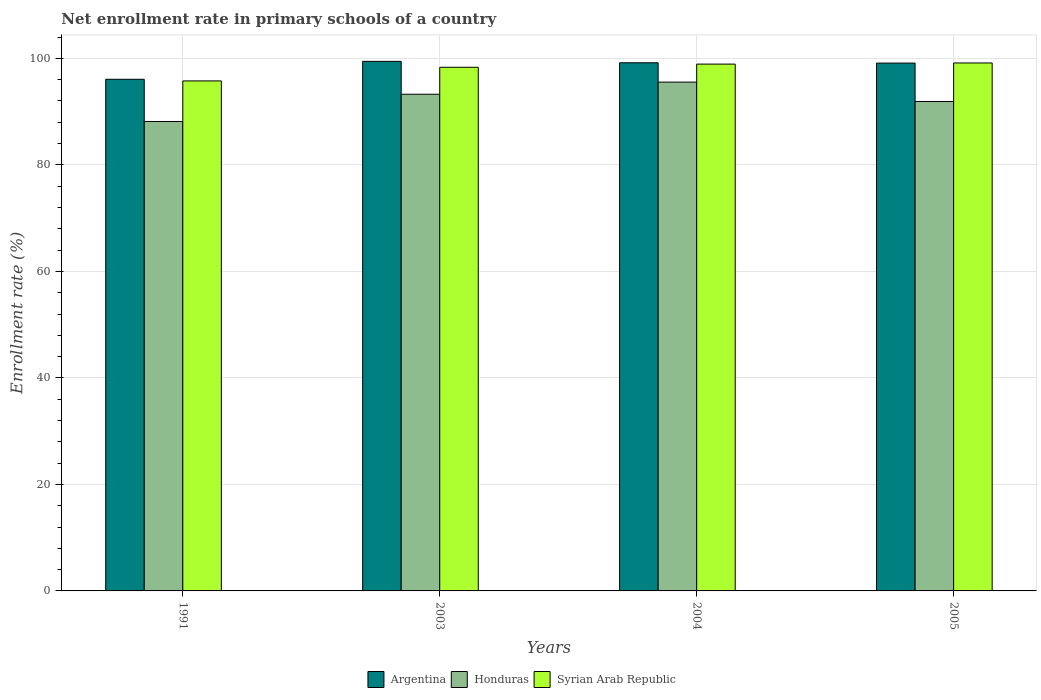How many different coloured bars are there?
Offer a very short reply. 3. How many groups of bars are there?
Offer a very short reply. 4. Are the number of bars per tick equal to the number of legend labels?
Provide a short and direct response. Yes. What is the label of the 2nd group of bars from the left?
Provide a short and direct response. 2003. What is the enrollment rate in primary schools in Syrian Arab Republic in 2003?
Offer a terse response. 98.33. Across all years, what is the maximum enrollment rate in primary schools in Syrian Arab Republic?
Your answer should be compact. 99.14. Across all years, what is the minimum enrollment rate in primary schools in Argentina?
Make the answer very short. 96.08. What is the total enrollment rate in primary schools in Argentina in the graph?
Give a very brief answer. 393.82. What is the difference between the enrollment rate in primary schools in Syrian Arab Republic in 1991 and that in 2004?
Your answer should be very brief. -3.16. What is the difference between the enrollment rate in primary schools in Argentina in 2003 and the enrollment rate in primary schools in Honduras in 2004?
Your response must be concise. 3.9. What is the average enrollment rate in primary schools in Syrian Arab Republic per year?
Offer a very short reply. 98.04. In the year 2005, what is the difference between the enrollment rate in primary schools in Honduras and enrollment rate in primary schools in Argentina?
Provide a succinct answer. -7.21. What is the ratio of the enrollment rate in primary schools in Honduras in 1991 to that in 2005?
Ensure brevity in your answer.  0.96. Is the enrollment rate in primary schools in Syrian Arab Republic in 2003 less than that in 2004?
Keep it short and to the point. Yes. Is the difference between the enrollment rate in primary schools in Honduras in 1991 and 2003 greater than the difference between the enrollment rate in primary schools in Argentina in 1991 and 2003?
Ensure brevity in your answer.  No. What is the difference between the highest and the second highest enrollment rate in primary schools in Honduras?
Ensure brevity in your answer.  2.28. What is the difference between the highest and the lowest enrollment rate in primary schools in Syrian Arab Republic?
Keep it short and to the point. 3.37. What does the 3rd bar from the left in 2005 represents?
Your answer should be very brief. Syrian Arab Republic. What does the 2nd bar from the right in 2005 represents?
Offer a terse response. Honduras. Is it the case that in every year, the sum of the enrollment rate in primary schools in Syrian Arab Republic and enrollment rate in primary schools in Honduras is greater than the enrollment rate in primary schools in Argentina?
Your answer should be very brief. Yes. How many bars are there?
Offer a very short reply. 12. How many years are there in the graph?
Your answer should be compact. 4. What is the difference between two consecutive major ticks on the Y-axis?
Make the answer very short. 20. Are the values on the major ticks of Y-axis written in scientific E-notation?
Provide a short and direct response. No. Does the graph contain any zero values?
Your response must be concise. No. Where does the legend appear in the graph?
Your answer should be compact. Bottom center. What is the title of the graph?
Keep it short and to the point. Net enrollment rate in primary schools of a country. What is the label or title of the X-axis?
Offer a terse response. Years. What is the label or title of the Y-axis?
Your answer should be very brief. Enrollment rate (%). What is the Enrollment rate (%) of Argentina in 1991?
Give a very brief answer. 96.08. What is the Enrollment rate (%) in Honduras in 1991?
Keep it short and to the point. 88.15. What is the Enrollment rate (%) in Syrian Arab Republic in 1991?
Make the answer very short. 95.77. What is the Enrollment rate (%) of Argentina in 2003?
Your response must be concise. 99.44. What is the Enrollment rate (%) of Honduras in 2003?
Your response must be concise. 93.27. What is the Enrollment rate (%) of Syrian Arab Republic in 2003?
Your response must be concise. 98.33. What is the Enrollment rate (%) in Argentina in 2004?
Keep it short and to the point. 99.18. What is the Enrollment rate (%) of Honduras in 2004?
Keep it short and to the point. 95.55. What is the Enrollment rate (%) in Syrian Arab Republic in 2004?
Make the answer very short. 98.93. What is the Enrollment rate (%) of Argentina in 2005?
Your answer should be compact. 99.12. What is the Enrollment rate (%) of Honduras in 2005?
Provide a succinct answer. 91.91. What is the Enrollment rate (%) of Syrian Arab Republic in 2005?
Your answer should be very brief. 99.14. Across all years, what is the maximum Enrollment rate (%) in Argentina?
Provide a succinct answer. 99.44. Across all years, what is the maximum Enrollment rate (%) in Honduras?
Provide a short and direct response. 95.55. Across all years, what is the maximum Enrollment rate (%) of Syrian Arab Republic?
Ensure brevity in your answer.  99.14. Across all years, what is the minimum Enrollment rate (%) in Argentina?
Offer a very short reply. 96.08. Across all years, what is the minimum Enrollment rate (%) of Honduras?
Your response must be concise. 88.15. Across all years, what is the minimum Enrollment rate (%) in Syrian Arab Republic?
Your answer should be very brief. 95.77. What is the total Enrollment rate (%) in Argentina in the graph?
Your answer should be very brief. 393.82. What is the total Enrollment rate (%) in Honduras in the graph?
Give a very brief answer. 368.87. What is the total Enrollment rate (%) in Syrian Arab Republic in the graph?
Your answer should be very brief. 392.18. What is the difference between the Enrollment rate (%) of Argentina in 1991 and that in 2003?
Your response must be concise. -3.36. What is the difference between the Enrollment rate (%) in Honduras in 1991 and that in 2003?
Your response must be concise. -5.12. What is the difference between the Enrollment rate (%) in Syrian Arab Republic in 1991 and that in 2003?
Keep it short and to the point. -2.56. What is the difference between the Enrollment rate (%) of Argentina in 1991 and that in 2004?
Your answer should be compact. -3.1. What is the difference between the Enrollment rate (%) in Honduras in 1991 and that in 2004?
Offer a very short reply. -7.4. What is the difference between the Enrollment rate (%) of Syrian Arab Republic in 1991 and that in 2004?
Make the answer very short. -3.16. What is the difference between the Enrollment rate (%) of Argentina in 1991 and that in 2005?
Provide a short and direct response. -3.04. What is the difference between the Enrollment rate (%) in Honduras in 1991 and that in 2005?
Keep it short and to the point. -3.76. What is the difference between the Enrollment rate (%) of Syrian Arab Republic in 1991 and that in 2005?
Make the answer very short. -3.37. What is the difference between the Enrollment rate (%) in Argentina in 2003 and that in 2004?
Provide a short and direct response. 0.27. What is the difference between the Enrollment rate (%) in Honduras in 2003 and that in 2004?
Your answer should be very brief. -2.28. What is the difference between the Enrollment rate (%) in Syrian Arab Republic in 2003 and that in 2004?
Make the answer very short. -0.6. What is the difference between the Enrollment rate (%) of Argentina in 2003 and that in 2005?
Your answer should be compact. 0.33. What is the difference between the Enrollment rate (%) in Honduras in 2003 and that in 2005?
Provide a succinct answer. 1.36. What is the difference between the Enrollment rate (%) of Syrian Arab Republic in 2003 and that in 2005?
Provide a succinct answer. -0.81. What is the difference between the Enrollment rate (%) in Argentina in 2004 and that in 2005?
Provide a succinct answer. 0.06. What is the difference between the Enrollment rate (%) in Honduras in 2004 and that in 2005?
Your response must be concise. 3.64. What is the difference between the Enrollment rate (%) of Syrian Arab Republic in 2004 and that in 2005?
Offer a very short reply. -0.21. What is the difference between the Enrollment rate (%) of Argentina in 1991 and the Enrollment rate (%) of Honduras in 2003?
Your response must be concise. 2.81. What is the difference between the Enrollment rate (%) of Argentina in 1991 and the Enrollment rate (%) of Syrian Arab Republic in 2003?
Offer a terse response. -2.25. What is the difference between the Enrollment rate (%) of Honduras in 1991 and the Enrollment rate (%) of Syrian Arab Republic in 2003?
Give a very brief answer. -10.19. What is the difference between the Enrollment rate (%) of Argentina in 1991 and the Enrollment rate (%) of Honduras in 2004?
Your answer should be very brief. 0.53. What is the difference between the Enrollment rate (%) in Argentina in 1991 and the Enrollment rate (%) in Syrian Arab Republic in 2004?
Provide a short and direct response. -2.85. What is the difference between the Enrollment rate (%) in Honduras in 1991 and the Enrollment rate (%) in Syrian Arab Republic in 2004?
Your answer should be compact. -10.78. What is the difference between the Enrollment rate (%) in Argentina in 1991 and the Enrollment rate (%) in Honduras in 2005?
Keep it short and to the point. 4.17. What is the difference between the Enrollment rate (%) of Argentina in 1991 and the Enrollment rate (%) of Syrian Arab Republic in 2005?
Offer a terse response. -3.06. What is the difference between the Enrollment rate (%) of Honduras in 1991 and the Enrollment rate (%) of Syrian Arab Republic in 2005?
Give a very brief answer. -11. What is the difference between the Enrollment rate (%) of Argentina in 2003 and the Enrollment rate (%) of Honduras in 2004?
Keep it short and to the point. 3.9. What is the difference between the Enrollment rate (%) of Argentina in 2003 and the Enrollment rate (%) of Syrian Arab Republic in 2004?
Provide a short and direct response. 0.51. What is the difference between the Enrollment rate (%) in Honduras in 2003 and the Enrollment rate (%) in Syrian Arab Republic in 2004?
Ensure brevity in your answer.  -5.66. What is the difference between the Enrollment rate (%) in Argentina in 2003 and the Enrollment rate (%) in Honduras in 2005?
Provide a short and direct response. 7.53. What is the difference between the Enrollment rate (%) in Argentina in 2003 and the Enrollment rate (%) in Syrian Arab Republic in 2005?
Make the answer very short. 0.3. What is the difference between the Enrollment rate (%) of Honduras in 2003 and the Enrollment rate (%) of Syrian Arab Republic in 2005?
Give a very brief answer. -5.87. What is the difference between the Enrollment rate (%) of Argentina in 2004 and the Enrollment rate (%) of Honduras in 2005?
Your answer should be compact. 7.27. What is the difference between the Enrollment rate (%) of Argentina in 2004 and the Enrollment rate (%) of Syrian Arab Republic in 2005?
Make the answer very short. 0.03. What is the difference between the Enrollment rate (%) in Honduras in 2004 and the Enrollment rate (%) in Syrian Arab Republic in 2005?
Offer a very short reply. -3.6. What is the average Enrollment rate (%) of Argentina per year?
Your response must be concise. 98.45. What is the average Enrollment rate (%) of Honduras per year?
Offer a very short reply. 92.22. What is the average Enrollment rate (%) in Syrian Arab Republic per year?
Provide a succinct answer. 98.04. In the year 1991, what is the difference between the Enrollment rate (%) of Argentina and Enrollment rate (%) of Honduras?
Offer a very short reply. 7.93. In the year 1991, what is the difference between the Enrollment rate (%) in Argentina and Enrollment rate (%) in Syrian Arab Republic?
Your answer should be very brief. 0.31. In the year 1991, what is the difference between the Enrollment rate (%) of Honduras and Enrollment rate (%) of Syrian Arab Republic?
Give a very brief answer. -7.62. In the year 2003, what is the difference between the Enrollment rate (%) in Argentina and Enrollment rate (%) in Honduras?
Ensure brevity in your answer.  6.18. In the year 2003, what is the difference between the Enrollment rate (%) of Argentina and Enrollment rate (%) of Syrian Arab Republic?
Your response must be concise. 1.11. In the year 2003, what is the difference between the Enrollment rate (%) of Honduras and Enrollment rate (%) of Syrian Arab Republic?
Ensure brevity in your answer.  -5.06. In the year 2004, what is the difference between the Enrollment rate (%) in Argentina and Enrollment rate (%) in Honduras?
Your response must be concise. 3.63. In the year 2004, what is the difference between the Enrollment rate (%) in Argentina and Enrollment rate (%) in Syrian Arab Republic?
Ensure brevity in your answer.  0.25. In the year 2004, what is the difference between the Enrollment rate (%) of Honduras and Enrollment rate (%) of Syrian Arab Republic?
Keep it short and to the point. -3.38. In the year 2005, what is the difference between the Enrollment rate (%) in Argentina and Enrollment rate (%) in Honduras?
Give a very brief answer. 7.21. In the year 2005, what is the difference between the Enrollment rate (%) in Argentina and Enrollment rate (%) in Syrian Arab Republic?
Ensure brevity in your answer.  -0.03. In the year 2005, what is the difference between the Enrollment rate (%) of Honduras and Enrollment rate (%) of Syrian Arab Republic?
Provide a succinct answer. -7.23. What is the ratio of the Enrollment rate (%) of Argentina in 1991 to that in 2003?
Your answer should be very brief. 0.97. What is the ratio of the Enrollment rate (%) in Honduras in 1991 to that in 2003?
Ensure brevity in your answer.  0.95. What is the ratio of the Enrollment rate (%) in Syrian Arab Republic in 1991 to that in 2003?
Keep it short and to the point. 0.97. What is the ratio of the Enrollment rate (%) of Argentina in 1991 to that in 2004?
Ensure brevity in your answer.  0.97. What is the ratio of the Enrollment rate (%) of Honduras in 1991 to that in 2004?
Give a very brief answer. 0.92. What is the ratio of the Enrollment rate (%) of Syrian Arab Republic in 1991 to that in 2004?
Give a very brief answer. 0.97. What is the ratio of the Enrollment rate (%) in Argentina in 1991 to that in 2005?
Your response must be concise. 0.97. What is the ratio of the Enrollment rate (%) of Honduras in 1991 to that in 2005?
Offer a very short reply. 0.96. What is the ratio of the Enrollment rate (%) in Argentina in 2003 to that in 2004?
Ensure brevity in your answer.  1. What is the ratio of the Enrollment rate (%) in Honduras in 2003 to that in 2004?
Offer a terse response. 0.98. What is the ratio of the Enrollment rate (%) in Syrian Arab Republic in 2003 to that in 2004?
Your answer should be very brief. 0.99. What is the ratio of the Enrollment rate (%) in Honduras in 2003 to that in 2005?
Offer a terse response. 1.01. What is the ratio of the Enrollment rate (%) in Honduras in 2004 to that in 2005?
Your answer should be compact. 1.04. What is the ratio of the Enrollment rate (%) in Syrian Arab Republic in 2004 to that in 2005?
Give a very brief answer. 1. What is the difference between the highest and the second highest Enrollment rate (%) in Argentina?
Give a very brief answer. 0.27. What is the difference between the highest and the second highest Enrollment rate (%) of Honduras?
Ensure brevity in your answer.  2.28. What is the difference between the highest and the second highest Enrollment rate (%) of Syrian Arab Republic?
Provide a short and direct response. 0.21. What is the difference between the highest and the lowest Enrollment rate (%) of Argentina?
Ensure brevity in your answer.  3.36. What is the difference between the highest and the lowest Enrollment rate (%) in Honduras?
Ensure brevity in your answer.  7.4. What is the difference between the highest and the lowest Enrollment rate (%) in Syrian Arab Republic?
Provide a succinct answer. 3.37. 